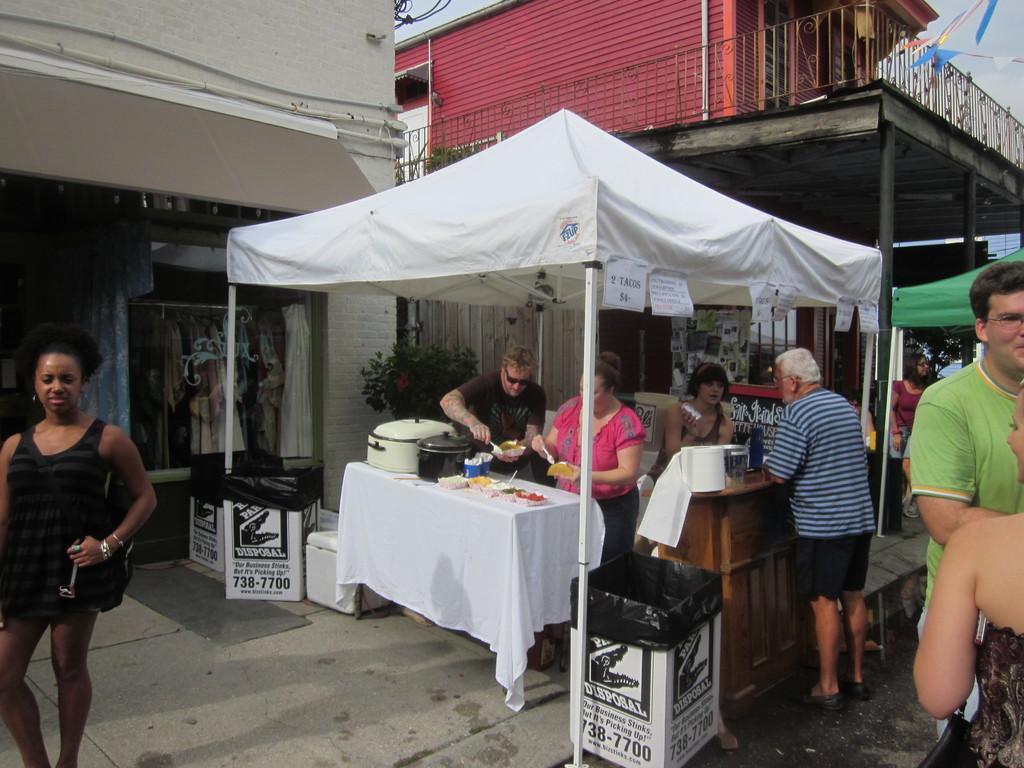Please provide a concise description of this image. This is a picture taken in the outdoors. In a stall there are three person standing on the floor. In front of the people there is a table covered with a white cloth on the table there are cups, bowl, spoon and some food items and also there is a wooden table on the table there is a tissue and bottle. In front of the people there are group of people standing on floor. Behind the stall there is a shop and building and sky. 